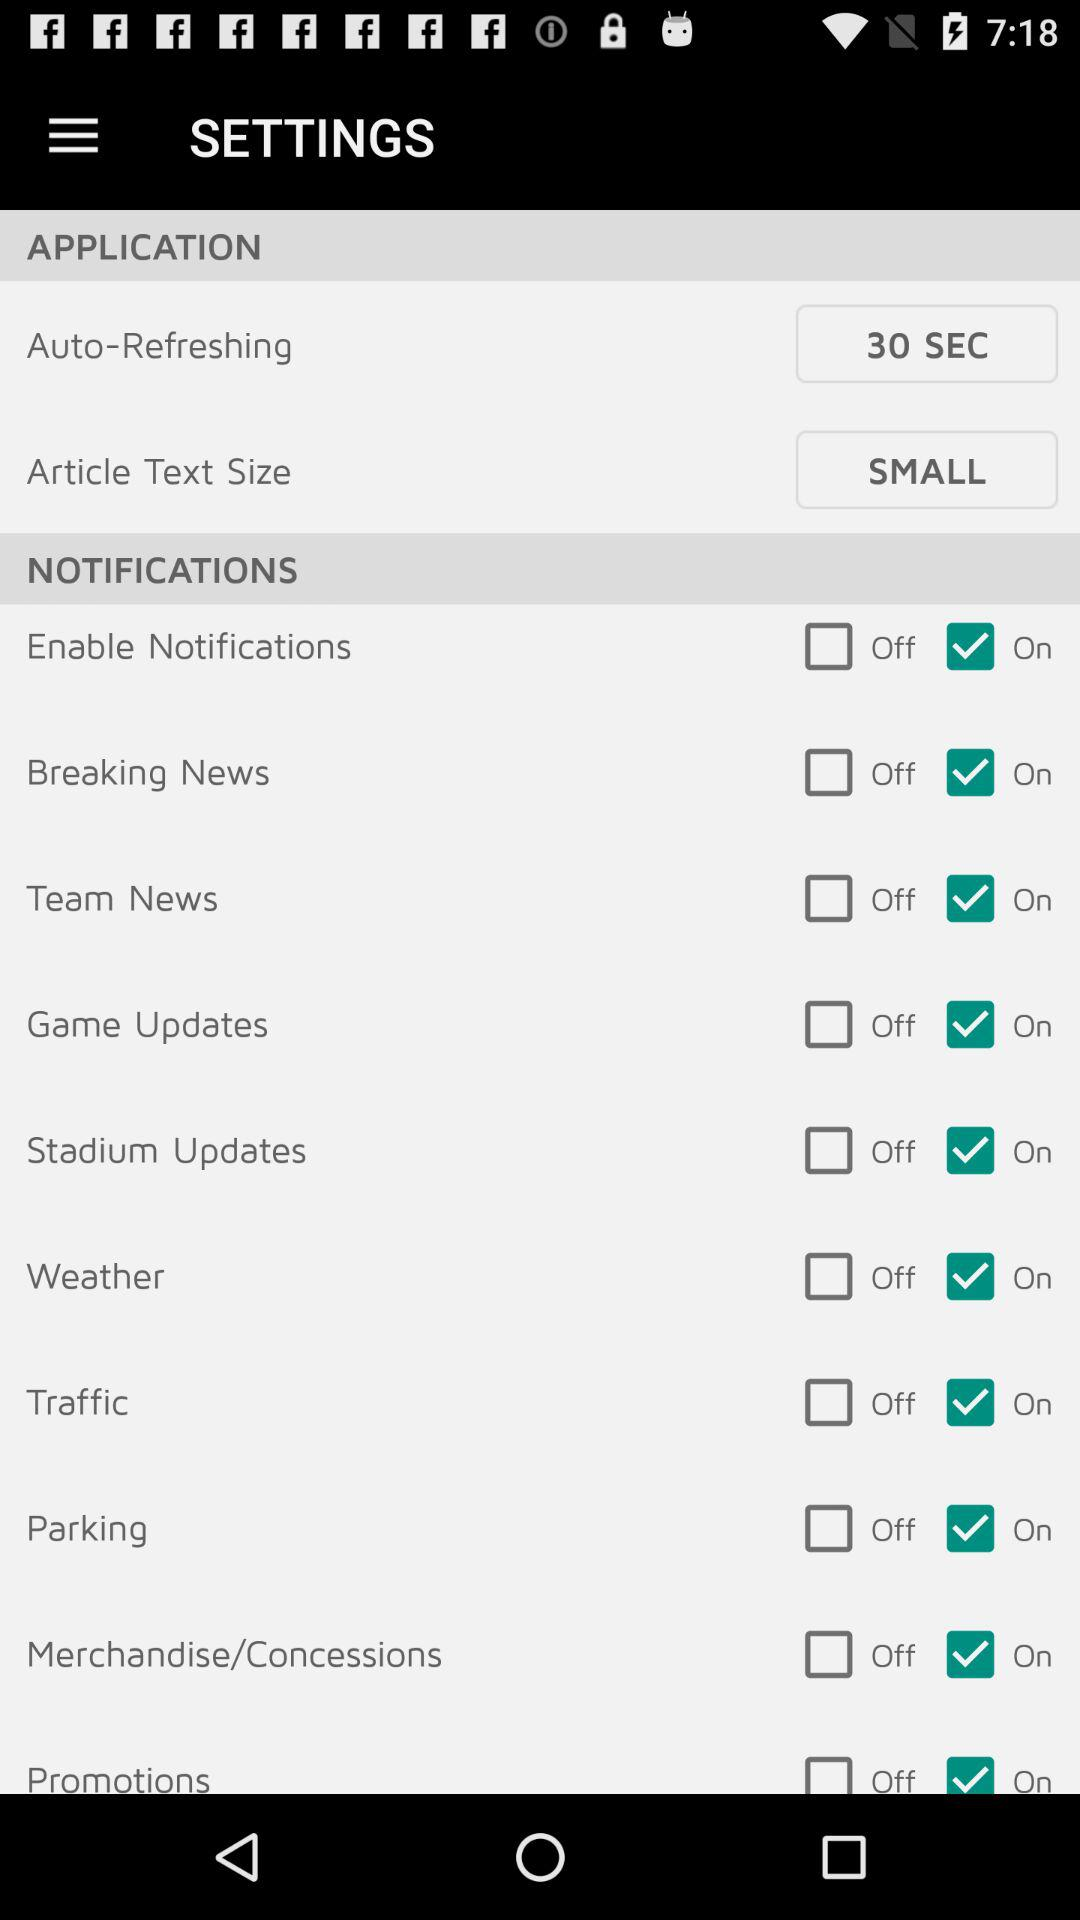What is the status of the "Weather"? The status is "On". 